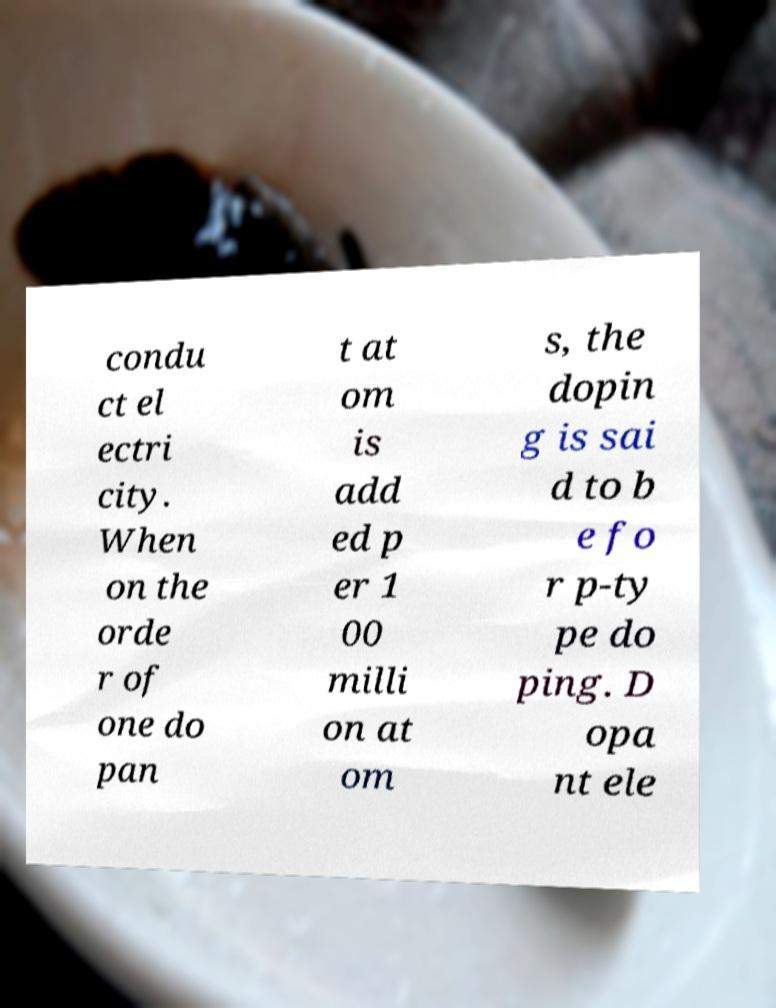Please identify and transcribe the text found in this image. condu ct el ectri city. When on the orde r of one do pan t at om is add ed p er 1 00 milli on at om s, the dopin g is sai d to b e fo r p-ty pe do ping. D opa nt ele 